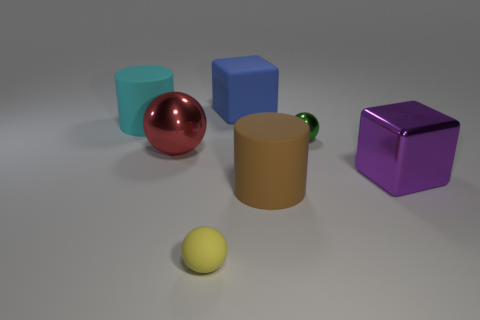How many purple objects are tiny balls or big metallic objects?
Your response must be concise. 1. The cube that is the same material as the brown thing is what size?
Your answer should be very brief. Large. How many cylinders are either large cyan matte things or green metallic things?
Provide a succinct answer. 1. Are there more tiny objects than big purple cubes?
Give a very brief answer. Yes. How many other cyan rubber cylinders are the same size as the cyan rubber cylinder?
Your response must be concise. 0. What number of objects are big blocks on the right side of the brown object or large green metallic things?
Offer a terse response. 1. Is the number of big shiny blocks less than the number of gray metallic balls?
Offer a very short reply. No. The cyan thing that is made of the same material as the large brown thing is what shape?
Keep it short and to the point. Cylinder. Are there any tiny objects behind the big shiny ball?
Keep it short and to the point. Yes. Are there fewer large brown things that are in front of the large brown rubber cylinder than blue spheres?
Offer a very short reply. No. 